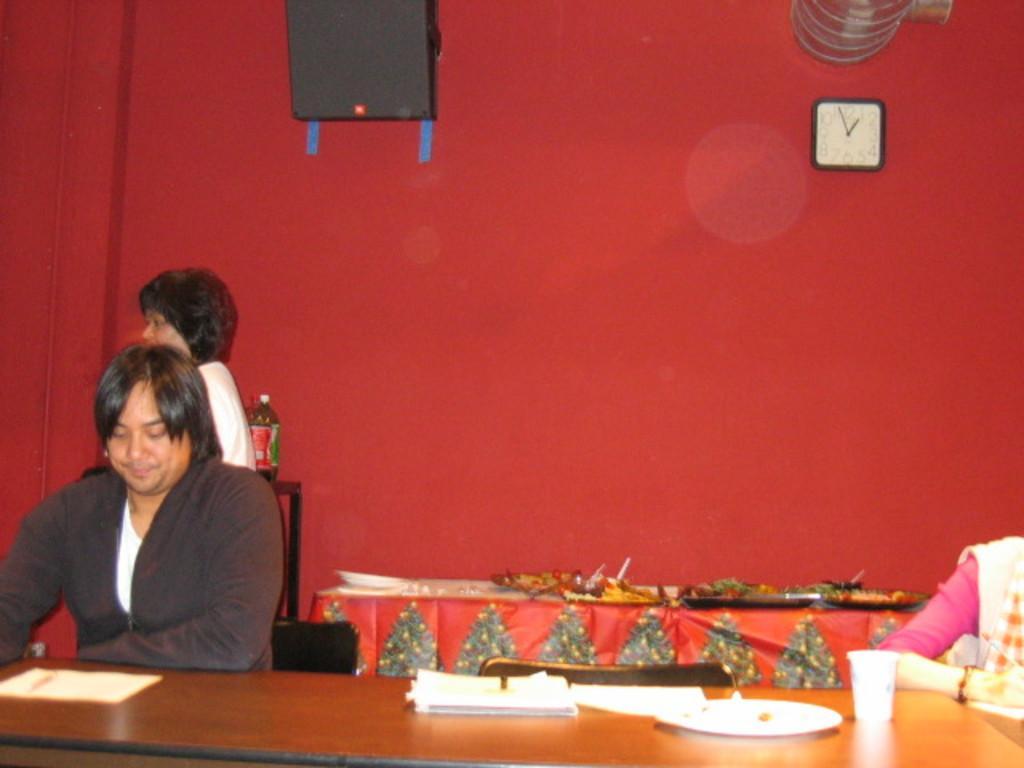Can you describe this image briefly? In this picture a man is sitting on the table. 